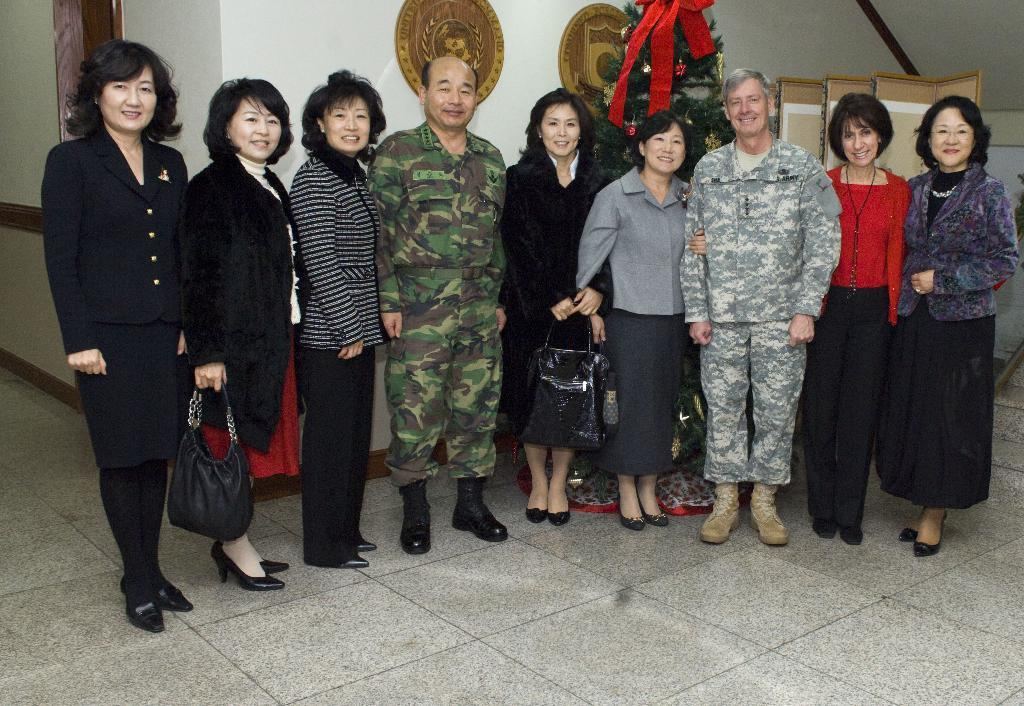What are the people in the image doing? The people in the image are standing in series in the center of the image. What else can be seen in the image besides the people? There are portraits in the image. Where is the decorative plant located in the image? The decorative plant is at the top side of the image. What type of hill can be seen in the background of the image? There is no hill visible in the image; it only features people standing in series, portraits, and a decorative plant. 